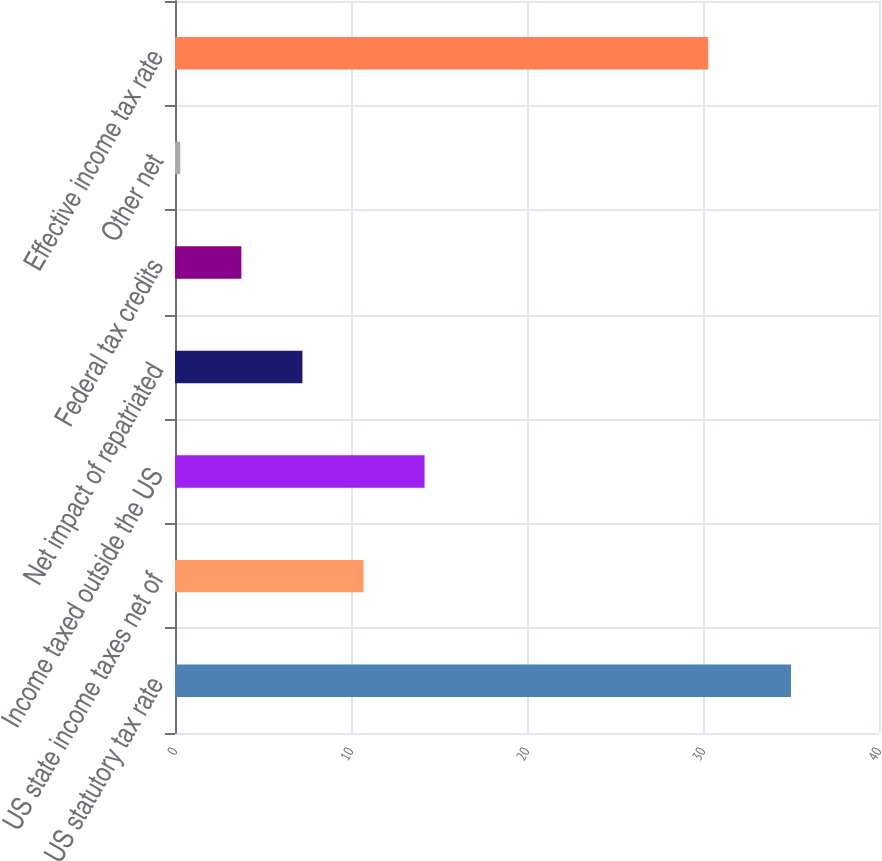Convert chart. <chart><loc_0><loc_0><loc_500><loc_500><bar_chart><fcel>US statutory tax rate<fcel>US state income taxes net of<fcel>Income taxed outside the US<fcel>Net impact of repatriated<fcel>Federal tax credits<fcel>Other net<fcel>Effective income tax rate<nl><fcel>35<fcel>10.71<fcel>14.18<fcel>7.24<fcel>3.77<fcel>0.3<fcel>30.3<nl></chart> 